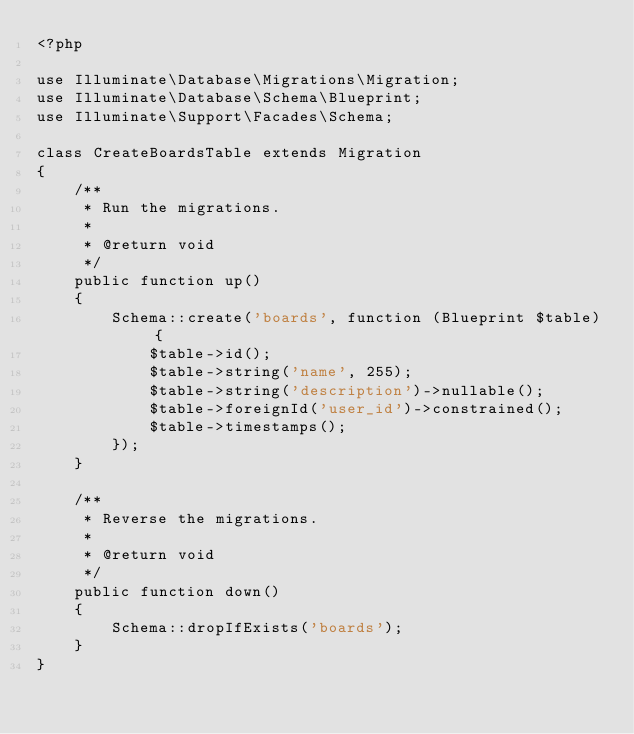Convert code to text. <code><loc_0><loc_0><loc_500><loc_500><_PHP_><?php

use Illuminate\Database\Migrations\Migration;
use Illuminate\Database\Schema\Blueprint;
use Illuminate\Support\Facades\Schema;

class CreateBoardsTable extends Migration
{
    /**
     * Run the migrations.
     *
     * @return void
     */
    public function up()
    {
        Schema::create('boards', function (Blueprint $table) {
            $table->id();
            $table->string('name', 255);
            $table->string('description')->nullable();
            $table->foreignId('user_id')->constrained();
            $table->timestamps();
        });
    }

    /**
     * Reverse the migrations.
     *
     * @return void
     */
    public function down()
    {
        Schema::dropIfExists('boards');
    }
}</code> 